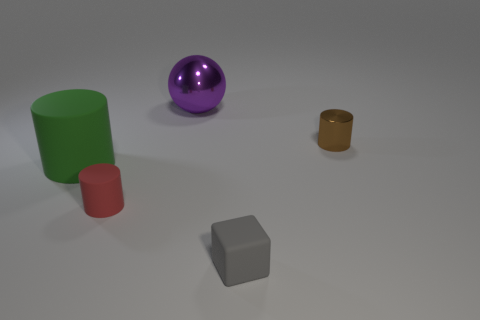Are there any purple things that have the same material as the green object?
Your answer should be compact. No. The large object that is on the left side of the large thing behind the brown object is made of what material?
Your answer should be very brief. Rubber. The cylinder that is in front of the metallic cylinder and on the right side of the large green rubber cylinder is made of what material?
Your answer should be very brief. Rubber. Are there the same number of small brown metal cylinders to the left of the red rubber cylinder and big red cubes?
Provide a succinct answer. Yes. What number of other things are the same shape as the big purple metallic object?
Your response must be concise. 0. How big is the cylinder on the right side of the object behind the cylinder that is right of the shiny sphere?
Your answer should be compact. Small. Do the tiny cylinder behind the big green rubber object and the tiny red cylinder have the same material?
Ensure brevity in your answer.  No. Are there the same number of gray matte objects on the left side of the tiny gray rubber block and brown metallic cylinders that are to the right of the large purple shiny object?
Provide a short and direct response. No. There is a brown object that is the same shape as the green object; what is its material?
Your response must be concise. Metal. There is a large green matte object that is to the left of the red thing that is in front of the brown cylinder; is there a gray thing behind it?
Keep it short and to the point. No. 